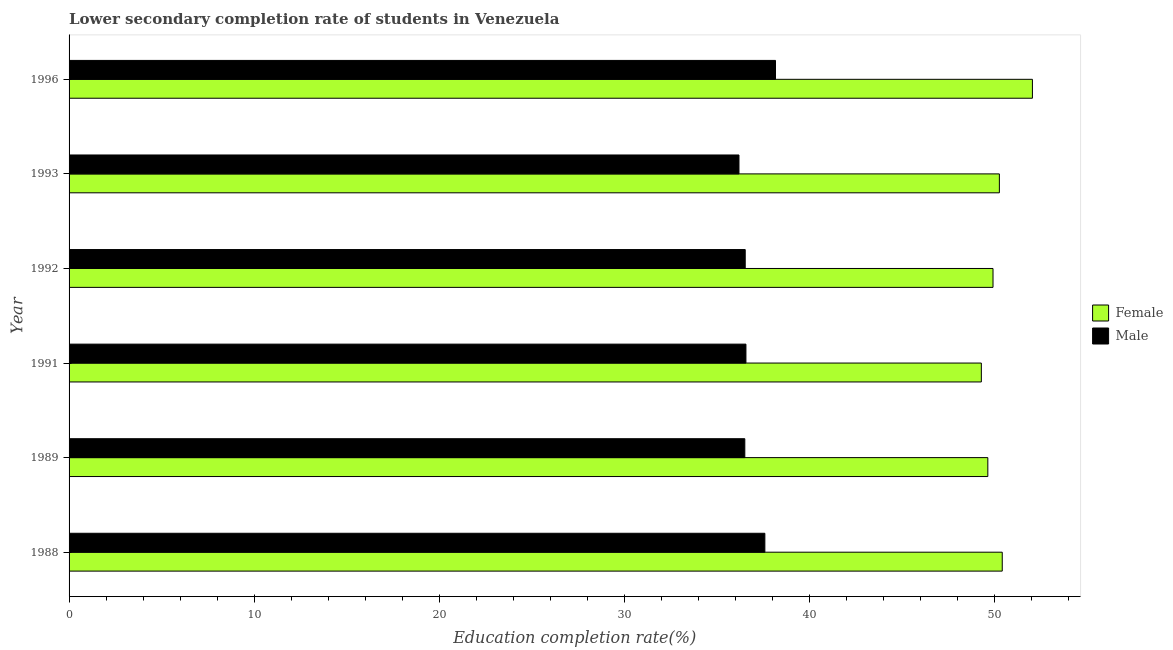How many different coloured bars are there?
Provide a succinct answer. 2. How many bars are there on the 6th tick from the bottom?
Offer a very short reply. 2. What is the label of the 5th group of bars from the top?
Offer a very short reply. 1989. What is the education completion rate of male students in 1992?
Provide a short and direct response. 36.53. Across all years, what is the maximum education completion rate of male students?
Offer a very short reply. 38.16. Across all years, what is the minimum education completion rate of male students?
Ensure brevity in your answer.  36.19. In which year was the education completion rate of female students maximum?
Give a very brief answer. 1996. What is the total education completion rate of female students in the graph?
Make the answer very short. 301.53. What is the difference between the education completion rate of female students in 1988 and that in 1993?
Your answer should be very brief. 0.15. What is the difference between the education completion rate of male students in 1996 and the education completion rate of female students in 1989?
Your response must be concise. -11.47. What is the average education completion rate of female students per year?
Provide a succinct answer. 50.25. In the year 1989, what is the difference between the education completion rate of male students and education completion rate of female students?
Your answer should be compact. -13.13. What is the ratio of the education completion rate of female students in 1989 to that in 1991?
Keep it short and to the point. 1.01. Is the education completion rate of female students in 1988 less than that in 1996?
Your response must be concise. Yes. What is the difference between the highest and the second highest education completion rate of male students?
Offer a very short reply. 0.57. What is the difference between the highest and the lowest education completion rate of female students?
Your answer should be compact. 2.76. In how many years, is the education completion rate of male students greater than the average education completion rate of male students taken over all years?
Provide a succinct answer. 2. What does the 2nd bar from the top in 1996 represents?
Give a very brief answer. Female. What does the 1st bar from the bottom in 1996 represents?
Offer a terse response. Female. How many bars are there?
Keep it short and to the point. 12. Are the values on the major ticks of X-axis written in scientific E-notation?
Provide a succinct answer. No. Does the graph contain any zero values?
Provide a succinct answer. No. Where does the legend appear in the graph?
Your response must be concise. Center right. How are the legend labels stacked?
Your answer should be very brief. Vertical. What is the title of the graph?
Offer a very short reply. Lower secondary completion rate of students in Venezuela. Does "Health Care" appear as one of the legend labels in the graph?
Provide a succinct answer. No. What is the label or title of the X-axis?
Provide a succinct answer. Education completion rate(%). What is the Education completion rate(%) in Female in 1988?
Give a very brief answer. 50.41. What is the Education completion rate(%) in Male in 1988?
Offer a very short reply. 37.59. What is the Education completion rate(%) in Female in 1989?
Offer a very short reply. 49.63. What is the Education completion rate(%) in Male in 1989?
Offer a terse response. 36.5. What is the Education completion rate(%) in Female in 1991?
Give a very brief answer. 49.28. What is the Education completion rate(%) in Male in 1991?
Your answer should be compact. 36.56. What is the Education completion rate(%) of Female in 1992?
Provide a short and direct response. 49.91. What is the Education completion rate(%) of Male in 1992?
Ensure brevity in your answer.  36.53. What is the Education completion rate(%) of Female in 1993?
Give a very brief answer. 50.25. What is the Education completion rate(%) of Male in 1993?
Provide a short and direct response. 36.19. What is the Education completion rate(%) of Female in 1996?
Make the answer very short. 52.04. What is the Education completion rate(%) of Male in 1996?
Your answer should be compact. 38.16. Across all years, what is the maximum Education completion rate(%) of Female?
Your answer should be very brief. 52.04. Across all years, what is the maximum Education completion rate(%) of Male?
Your response must be concise. 38.16. Across all years, what is the minimum Education completion rate(%) in Female?
Keep it short and to the point. 49.28. Across all years, what is the minimum Education completion rate(%) of Male?
Give a very brief answer. 36.19. What is the total Education completion rate(%) of Female in the graph?
Give a very brief answer. 301.53. What is the total Education completion rate(%) in Male in the graph?
Provide a short and direct response. 221.53. What is the difference between the Education completion rate(%) of Female in 1988 and that in 1989?
Offer a very short reply. 0.78. What is the difference between the Education completion rate(%) in Male in 1988 and that in 1989?
Your answer should be very brief. 1.08. What is the difference between the Education completion rate(%) of Female in 1988 and that in 1991?
Offer a very short reply. 1.13. What is the difference between the Education completion rate(%) in Male in 1988 and that in 1991?
Provide a short and direct response. 1.02. What is the difference between the Education completion rate(%) of Female in 1988 and that in 1992?
Ensure brevity in your answer.  0.5. What is the difference between the Education completion rate(%) in Male in 1988 and that in 1992?
Ensure brevity in your answer.  1.06. What is the difference between the Education completion rate(%) of Female in 1988 and that in 1993?
Your response must be concise. 0.16. What is the difference between the Education completion rate(%) of Male in 1988 and that in 1993?
Keep it short and to the point. 1.4. What is the difference between the Education completion rate(%) of Female in 1988 and that in 1996?
Offer a very short reply. -1.63. What is the difference between the Education completion rate(%) of Male in 1988 and that in 1996?
Provide a short and direct response. -0.57. What is the difference between the Education completion rate(%) of Female in 1989 and that in 1991?
Keep it short and to the point. 0.35. What is the difference between the Education completion rate(%) of Male in 1989 and that in 1991?
Your response must be concise. -0.06. What is the difference between the Education completion rate(%) in Female in 1989 and that in 1992?
Provide a short and direct response. -0.28. What is the difference between the Education completion rate(%) of Male in 1989 and that in 1992?
Provide a short and direct response. -0.02. What is the difference between the Education completion rate(%) in Female in 1989 and that in 1993?
Ensure brevity in your answer.  -0.62. What is the difference between the Education completion rate(%) of Male in 1989 and that in 1993?
Ensure brevity in your answer.  0.32. What is the difference between the Education completion rate(%) in Female in 1989 and that in 1996?
Offer a very short reply. -2.41. What is the difference between the Education completion rate(%) in Male in 1989 and that in 1996?
Ensure brevity in your answer.  -1.66. What is the difference between the Education completion rate(%) of Female in 1991 and that in 1992?
Make the answer very short. -0.63. What is the difference between the Education completion rate(%) of Male in 1991 and that in 1992?
Keep it short and to the point. 0.04. What is the difference between the Education completion rate(%) of Female in 1991 and that in 1993?
Offer a very short reply. -0.97. What is the difference between the Education completion rate(%) of Male in 1991 and that in 1993?
Offer a very short reply. 0.38. What is the difference between the Education completion rate(%) of Female in 1991 and that in 1996?
Your answer should be very brief. -2.76. What is the difference between the Education completion rate(%) of Male in 1991 and that in 1996?
Make the answer very short. -1.6. What is the difference between the Education completion rate(%) in Female in 1992 and that in 1993?
Your response must be concise. -0.34. What is the difference between the Education completion rate(%) in Male in 1992 and that in 1993?
Keep it short and to the point. 0.34. What is the difference between the Education completion rate(%) of Female in 1992 and that in 1996?
Ensure brevity in your answer.  -2.13. What is the difference between the Education completion rate(%) in Male in 1992 and that in 1996?
Your answer should be compact. -1.64. What is the difference between the Education completion rate(%) of Female in 1993 and that in 1996?
Give a very brief answer. -1.78. What is the difference between the Education completion rate(%) of Male in 1993 and that in 1996?
Ensure brevity in your answer.  -1.97. What is the difference between the Education completion rate(%) in Female in 1988 and the Education completion rate(%) in Male in 1989?
Ensure brevity in your answer.  13.91. What is the difference between the Education completion rate(%) of Female in 1988 and the Education completion rate(%) of Male in 1991?
Give a very brief answer. 13.85. What is the difference between the Education completion rate(%) in Female in 1988 and the Education completion rate(%) in Male in 1992?
Give a very brief answer. 13.88. What is the difference between the Education completion rate(%) in Female in 1988 and the Education completion rate(%) in Male in 1993?
Offer a terse response. 14.22. What is the difference between the Education completion rate(%) of Female in 1988 and the Education completion rate(%) of Male in 1996?
Give a very brief answer. 12.25. What is the difference between the Education completion rate(%) in Female in 1989 and the Education completion rate(%) in Male in 1991?
Offer a terse response. 13.07. What is the difference between the Education completion rate(%) of Female in 1989 and the Education completion rate(%) of Male in 1992?
Provide a succinct answer. 13.11. What is the difference between the Education completion rate(%) of Female in 1989 and the Education completion rate(%) of Male in 1993?
Your response must be concise. 13.44. What is the difference between the Education completion rate(%) of Female in 1989 and the Education completion rate(%) of Male in 1996?
Ensure brevity in your answer.  11.47. What is the difference between the Education completion rate(%) in Female in 1991 and the Education completion rate(%) in Male in 1992?
Make the answer very short. 12.76. What is the difference between the Education completion rate(%) in Female in 1991 and the Education completion rate(%) in Male in 1993?
Give a very brief answer. 13.09. What is the difference between the Education completion rate(%) in Female in 1991 and the Education completion rate(%) in Male in 1996?
Make the answer very short. 11.12. What is the difference between the Education completion rate(%) in Female in 1992 and the Education completion rate(%) in Male in 1993?
Offer a very short reply. 13.72. What is the difference between the Education completion rate(%) of Female in 1992 and the Education completion rate(%) of Male in 1996?
Your response must be concise. 11.75. What is the difference between the Education completion rate(%) in Female in 1993 and the Education completion rate(%) in Male in 1996?
Give a very brief answer. 12.09. What is the average Education completion rate(%) of Female per year?
Offer a terse response. 50.25. What is the average Education completion rate(%) in Male per year?
Offer a terse response. 36.92. In the year 1988, what is the difference between the Education completion rate(%) in Female and Education completion rate(%) in Male?
Your answer should be very brief. 12.82. In the year 1989, what is the difference between the Education completion rate(%) in Female and Education completion rate(%) in Male?
Ensure brevity in your answer.  13.13. In the year 1991, what is the difference between the Education completion rate(%) of Female and Education completion rate(%) of Male?
Keep it short and to the point. 12.72. In the year 1992, what is the difference between the Education completion rate(%) of Female and Education completion rate(%) of Male?
Provide a succinct answer. 13.39. In the year 1993, what is the difference between the Education completion rate(%) in Female and Education completion rate(%) in Male?
Your answer should be very brief. 14.07. In the year 1996, what is the difference between the Education completion rate(%) in Female and Education completion rate(%) in Male?
Make the answer very short. 13.88. What is the ratio of the Education completion rate(%) of Female in 1988 to that in 1989?
Provide a short and direct response. 1.02. What is the ratio of the Education completion rate(%) in Male in 1988 to that in 1989?
Provide a short and direct response. 1.03. What is the ratio of the Education completion rate(%) in Female in 1988 to that in 1991?
Provide a short and direct response. 1.02. What is the ratio of the Education completion rate(%) of Male in 1988 to that in 1991?
Give a very brief answer. 1.03. What is the ratio of the Education completion rate(%) in Male in 1988 to that in 1992?
Give a very brief answer. 1.03. What is the ratio of the Education completion rate(%) in Male in 1988 to that in 1993?
Offer a very short reply. 1.04. What is the ratio of the Education completion rate(%) in Female in 1988 to that in 1996?
Your response must be concise. 0.97. What is the ratio of the Education completion rate(%) of Male in 1988 to that in 1996?
Ensure brevity in your answer.  0.98. What is the ratio of the Education completion rate(%) in Female in 1989 to that in 1991?
Give a very brief answer. 1.01. What is the ratio of the Education completion rate(%) of Male in 1989 to that in 1991?
Offer a very short reply. 1. What is the ratio of the Education completion rate(%) in Female in 1989 to that in 1992?
Your answer should be compact. 0.99. What is the ratio of the Education completion rate(%) in Male in 1989 to that in 1992?
Your response must be concise. 1. What is the ratio of the Education completion rate(%) of Female in 1989 to that in 1993?
Keep it short and to the point. 0.99. What is the ratio of the Education completion rate(%) of Male in 1989 to that in 1993?
Your answer should be very brief. 1.01. What is the ratio of the Education completion rate(%) in Female in 1989 to that in 1996?
Your answer should be very brief. 0.95. What is the ratio of the Education completion rate(%) in Male in 1989 to that in 1996?
Your answer should be compact. 0.96. What is the ratio of the Education completion rate(%) in Female in 1991 to that in 1992?
Keep it short and to the point. 0.99. What is the ratio of the Education completion rate(%) of Male in 1991 to that in 1992?
Keep it short and to the point. 1. What is the ratio of the Education completion rate(%) in Female in 1991 to that in 1993?
Provide a short and direct response. 0.98. What is the ratio of the Education completion rate(%) in Male in 1991 to that in 1993?
Keep it short and to the point. 1.01. What is the ratio of the Education completion rate(%) in Female in 1991 to that in 1996?
Give a very brief answer. 0.95. What is the ratio of the Education completion rate(%) in Male in 1991 to that in 1996?
Keep it short and to the point. 0.96. What is the ratio of the Education completion rate(%) in Male in 1992 to that in 1993?
Your response must be concise. 1.01. What is the ratio of the Education completion rate(%) in Female in 1992 to that in 1996?
Provide a succinct answer. 0.96. What is the ratio of the Education completion rate(%) in Male in 1992 to that in 1996?
Offer a very short reply. 0.96. What is the ratio of the Education completion rate(%) of Female in 1993 to that in 1996?
Your response must be concise. 0.97. What is the ratio of the Education completion rate(%) of Male in 1993 to that in 1996?
Your response must be concise. 0.95. What is the difference between the highest and the second highest Education completion rate(%) in Female?
Offer a very short reply. 1.63. What is the difference between the highest and the second highest Education completion rate(%) in Male?
Your answer should be compact. 0.57. What is the difference between the highest and the lowest Education completion rate(%) in Female?
Offer a very short reply. 2.76. What is the difference between the highest and the lowest Education completion rate(%) of Male?
Offer a very short reply. 1.97. 